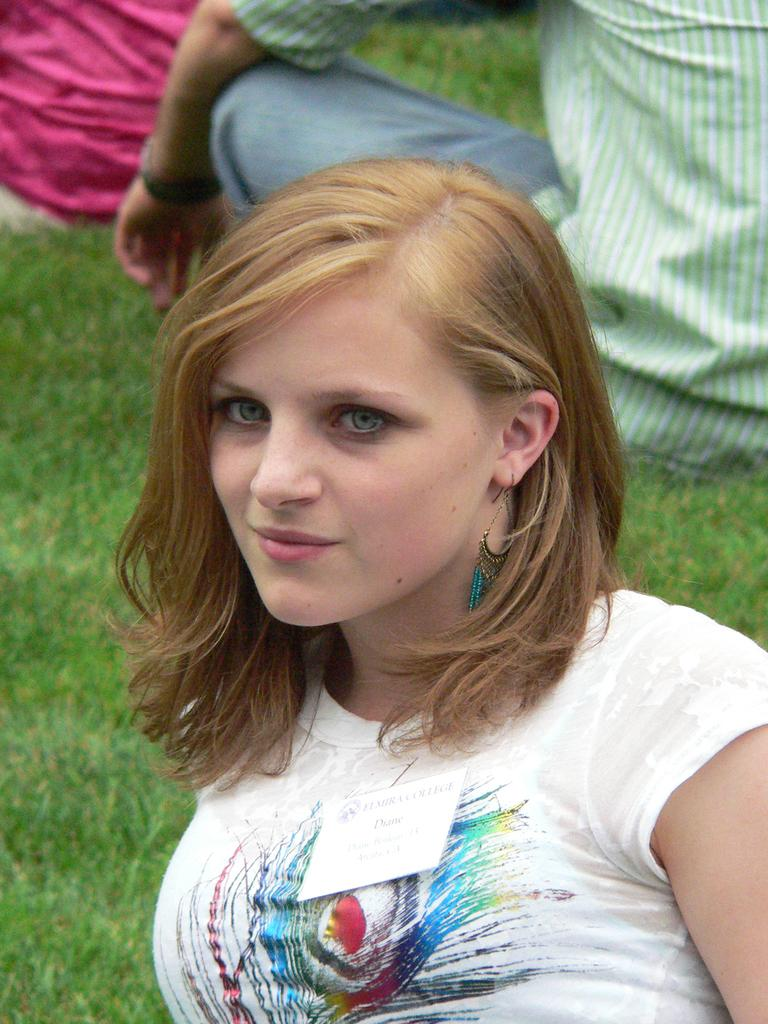Who is the main subject in the front of the image? There is a woman in the front of the image. What type of terrain is visible at the bottom of the image? There is grass at the bottom of the image. Can you describe the person in the background of the image? There is another person in the background of the image. What type of quartz can be seen on the stage in the image? There is no stage or quartz present in the image. Who is the manager of the woman in the image? The provided facts do not mention a manager or any relationship between the woman and another person. 